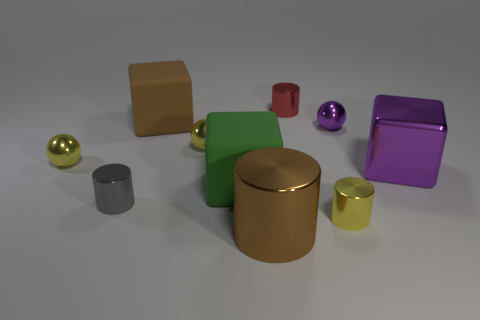What colors are the shiny spheres in the image? The shiny spheres in the image are gold, purple, and silver. How does their shininess compare to the other objects? The shiny spheres reflect more light and have more specular highlights compared to the matte surfaces of the cubes and cylinders, giving them a more lustrous appearance. 